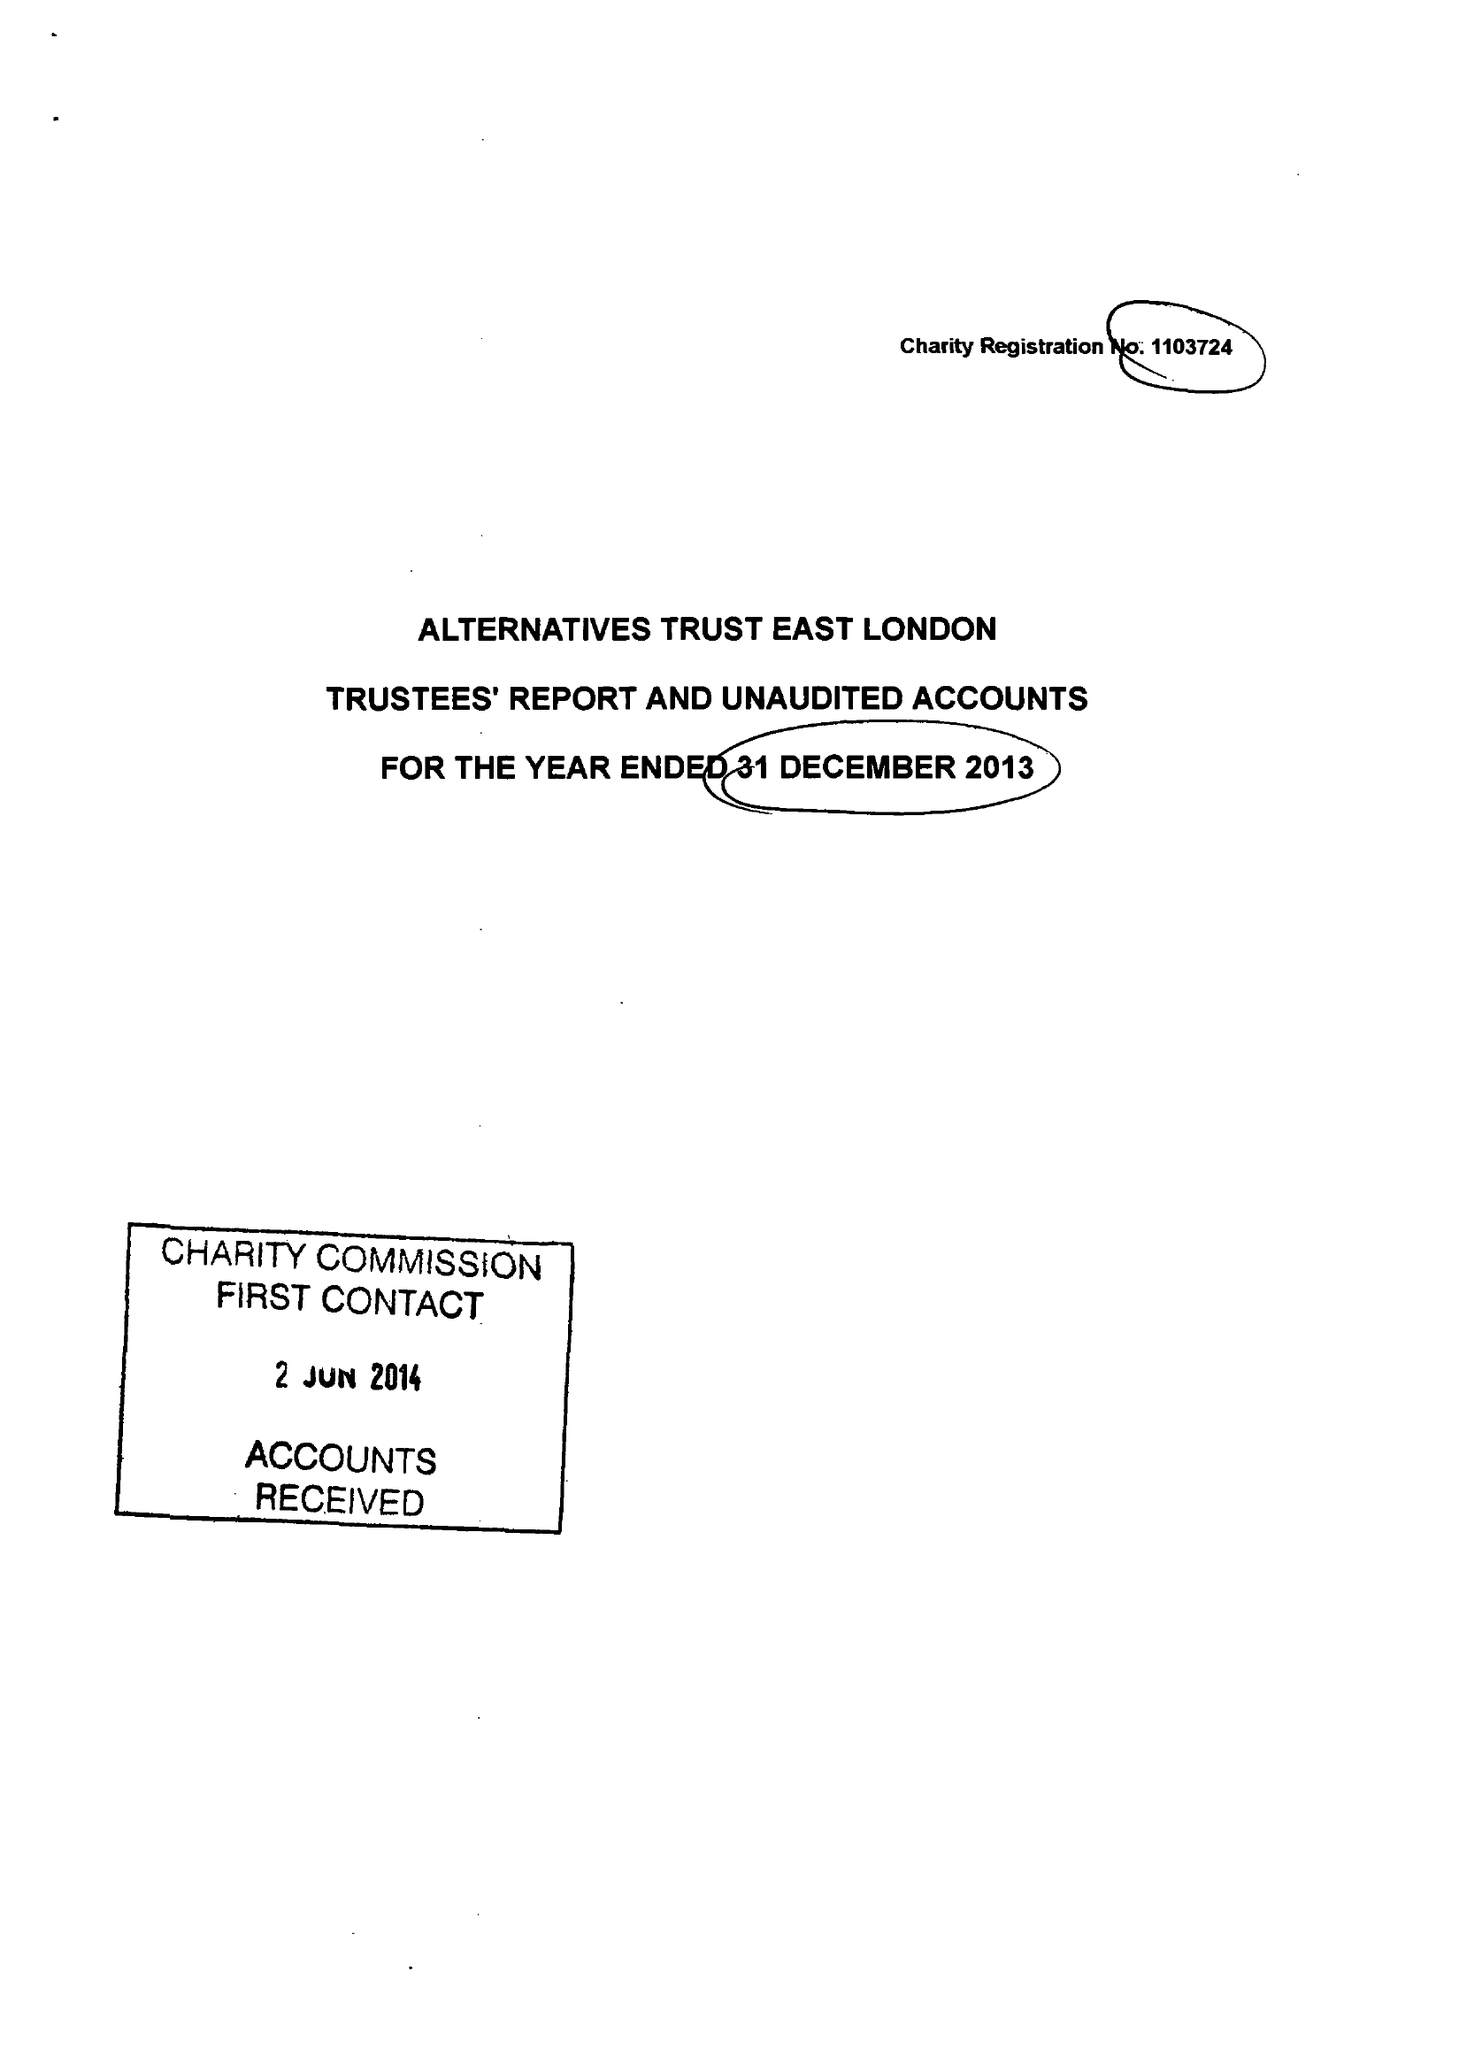What is the value for the charity_number?
Answer the question using a single word or phrase. 1103724 